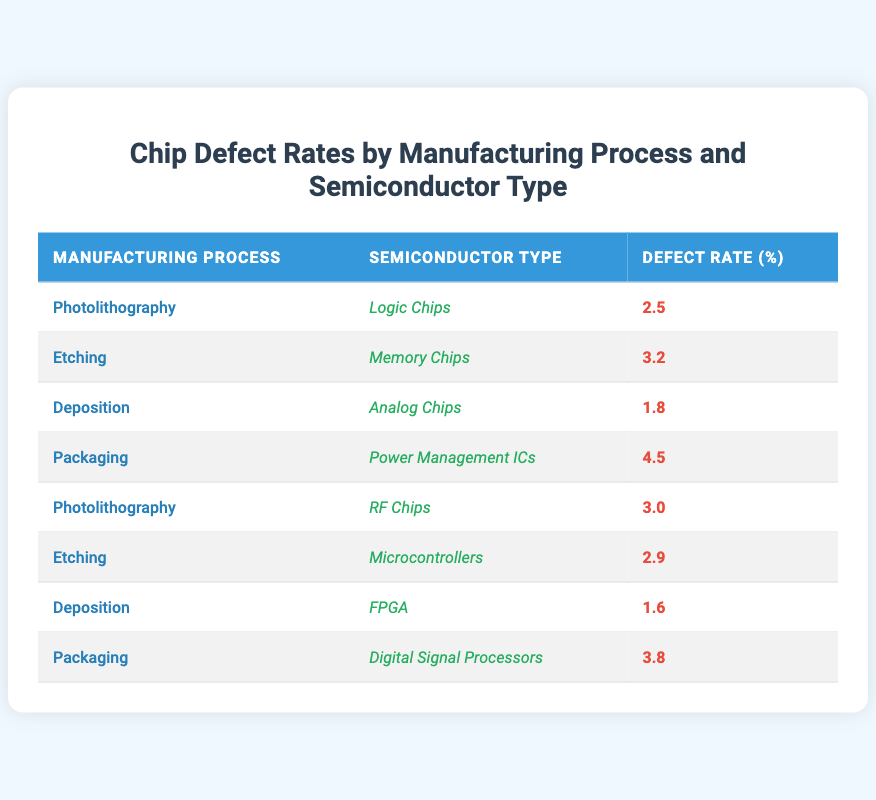What is the defect rate for Memory Chips using the Etching process? The defect rate for Memory Chips is listed in the table under the Etching manufacturing process, which shows a defect rate of 3.2.
Answer: 3.2 Which semiconductor type has the highest defect rate, and what is that rate? Looking at the defect rates in the table, the highest defect rate is listed for Power Management ICs under the Packaging process at 4.5.
Answer: Power Management ICs, 4.5 What is the average defect rate for the Photolithography process? The table shows defect rates for Photolithography being 2.5 for Logic Chips and 3.0 for RF Chips. Calculating the average: (2.5 + 3.0) / 2 = 2.75.
Answer: 2.75 Is the defect rate for Analog Chips lower than the defect rate for Digital Signal Processors? The defect rate for Analog Chips is 1.8 while the rate for Digital Signal Processors is 3.8. Since 1.8 is indeed lower than 3.8, the statement is true.
Answer: Yes What is the total defect rate for all types of chips made using the Deposition process? The defect rates for Deposition are 1.8 for Analog Chips and 1.6 for FPGA. Adding these two rates gives us: 1.8 + 1.6 = 3.4.
Answer: 3.4 Which manufacturing process has a defect rate greater than 3.0 and for which semiconductor types? The Packaging process has a defect rate of 4.5 (Power Management ICs) and 3.8 (Digital Signal Processors), both greater than 3.0, while Etching has a rate of 3.2 (Memory Chips) and 2.9 (Microcontrollers), making them the processes that meet this criterion.
Answer: Packaging (Power Management ICs, Digital Signal Processors), Etching (Memory Chips) Is it true that all semiconductor types listed undergo the same manufacturing process? No, the table clearly shows diverse semiconductor types being produced through different manufacturing processes, indicating that they do not all share the same process.
Answer: No What is the difference in defect rates between the higher defect rate of the two types produced by the Deposition process? For the Deposition process, the defect rates are 1.8 for Analog Chips and 1.6 for FPGAs. The difference is 1.8 - 1.6 = 0.2.
Answer: 0.2 